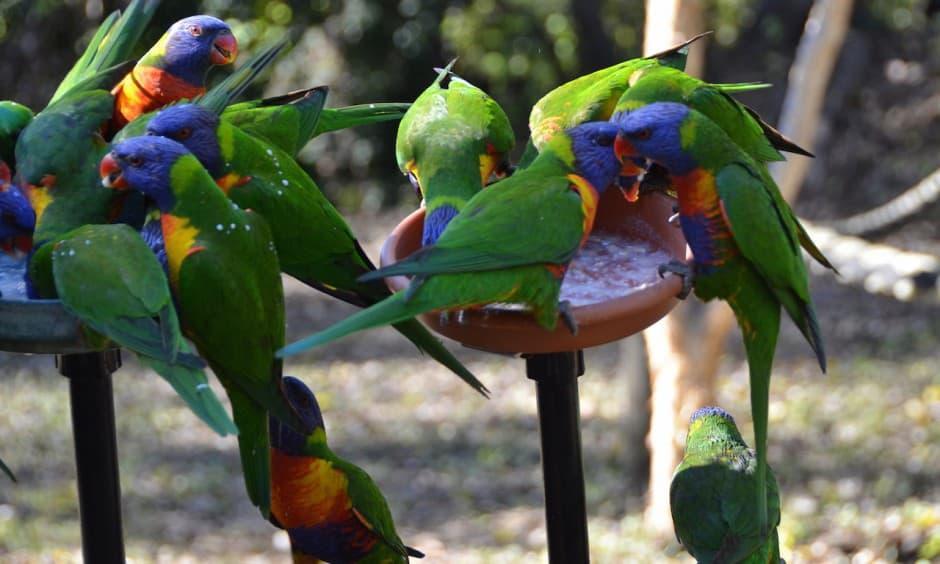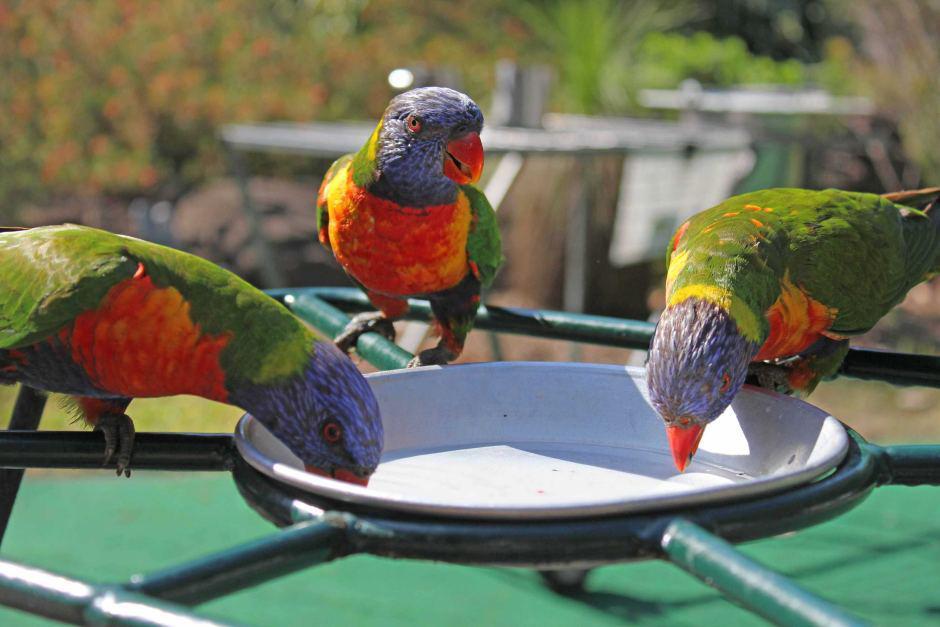The first image is the image on the left, the second image is the image on the right. For the images displayed, is the sentence "At least one image shows a group of parrots around some kind of round container for food or drink." factually correct? Answer yes or no. Yes. The first image is the image on the left, the second image is the image on the right. Evaluate the accuracy of this statement regarding the images: "A single bird perches on a branch outside in one of the images.". Is it true? Answer yes or no. No. 